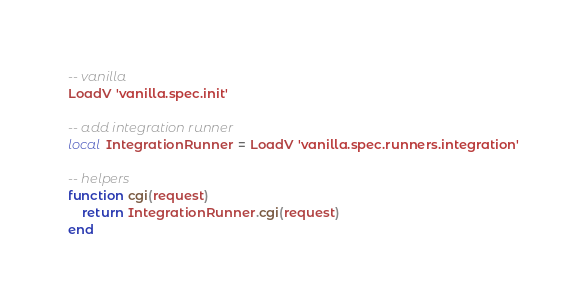<code> <loc_0><loc_0><loc_500><loc_500><_Lua_>-- vanilla
LoadV 'vanilla.spec.init'

-- add integration runner
local IntegrationRunner = LoadV 'vanilla.spec.runners.integration'

-- helpers
function cgi(request)
    return IntegrationRunner.cgi(request)
end
</code> 